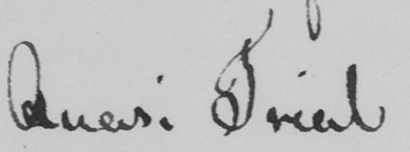What is written in this line of handwriting? Quasi Trial 